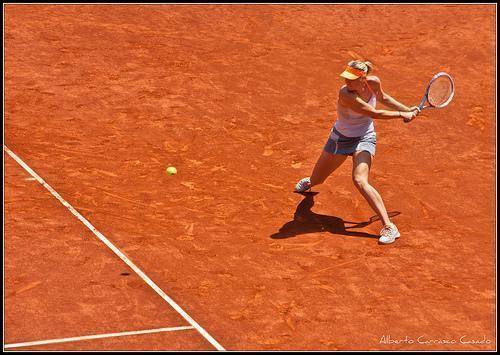How many hands are holding the racquet?
Give a very brief answer. 2. How many white lines are on the court?
Give a very brief answer. 2. 